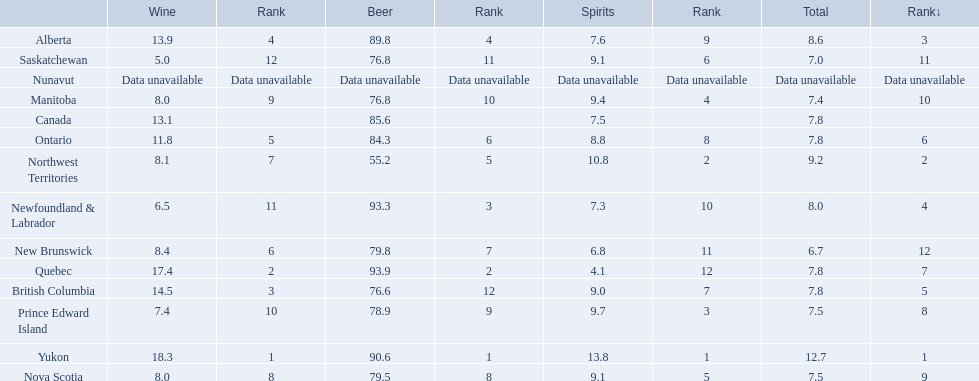Which locations consume the same total amount of alcoholic beverages as another location? British Columbia, Ontario, Quebec, Prince Edward Island, Nova Scotia. Which of these consumes more then 80 of beer? Ontario, Quebec. Of those what was the consumption of spirits of the one that consumed the most beer? 4.1. What are all the canadian regions? Yukon, Northwest Territories, Alberta, Newfoundland & Labrador, British Columbia, Ontario, Quebec, Prince Edward Island, Nova Scotia, Manitoba, Saskatchewan, New Brunswick, Nunavut, Canada. What was the spirits consumption? 13.8, 10.8, 7.6, 7.3, 9.0, 8.8, 4.1, 9.7, 9.1, 9.4, 9.1, 6.8, Data unavailable, 7.5. What was quebec's spirit consumption? 4.1. 